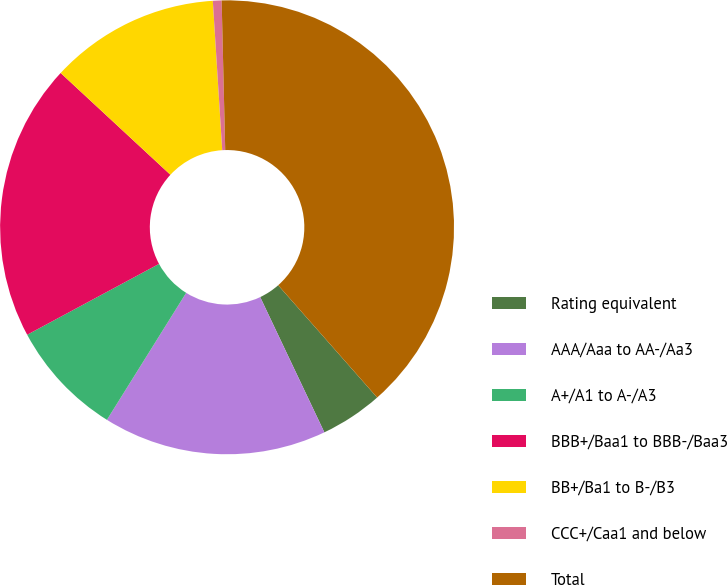Convert chart. <chart><loc_0><loc_0><loc_500><loc_500><pie_chart><fcel>Rating equivalent<fcel>AAA/Aaa to AA-/Aa3<fcel>A+/A1 to A-/A3<fcel>BBB+/Baa1 to BBB-/Baa3<fcel>BB+/Ba1 to B-/B3<fcel>CCC+/Caa1 and below<fcel>Total<nl><fcel>4.45%<fcel>15.93%<fcel>8.27%<fcel>19.75%<fcel>12.1%<fcel>0.62%<fcel>38.88%<nl></chart> 